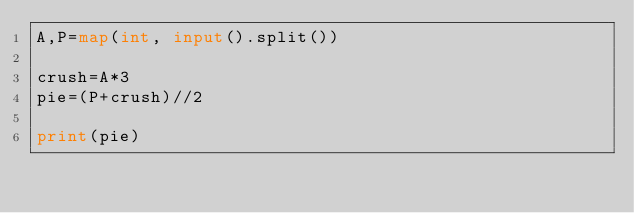<code> <loc_0><loc_0><loc_500><loc_500><_Python_>A,P=map(int, input().split()) 

crush=A*3
pie=(P+crush)//2

print(pie)</code> 